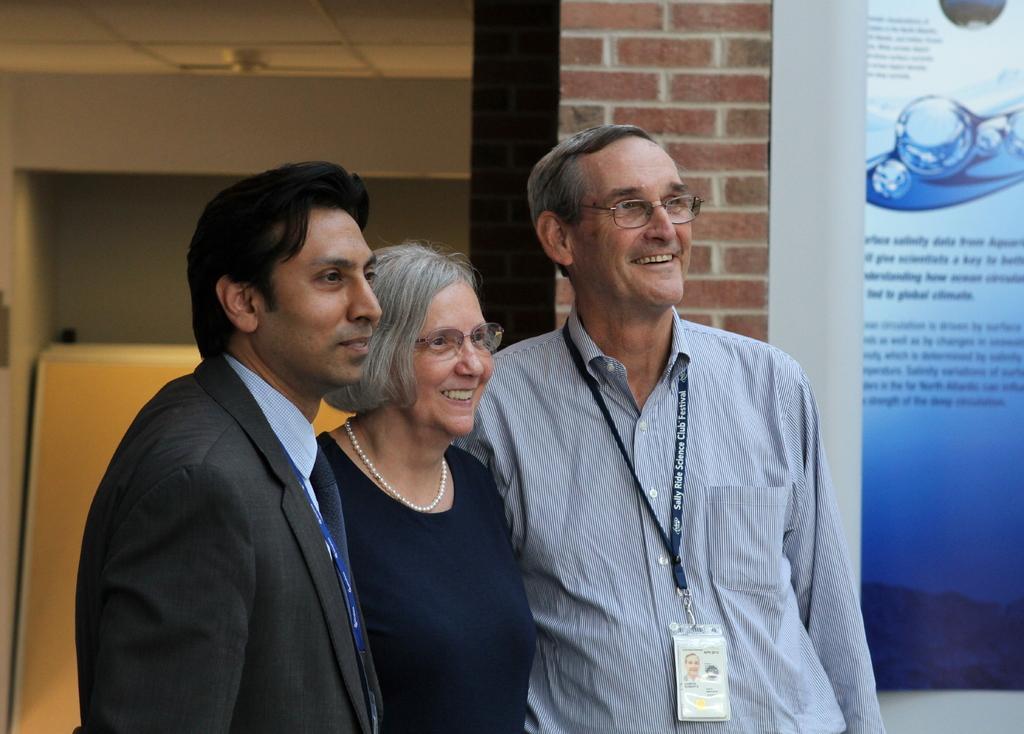Can you describe this image briefly? In the image we can see two men and a woman standing wearing clothes and they are smiling. Two of them are wearing spectacles, identity card and the woman is wearing a neck chain. Here we can see the poster and text on it and here we can see the brick wall. 